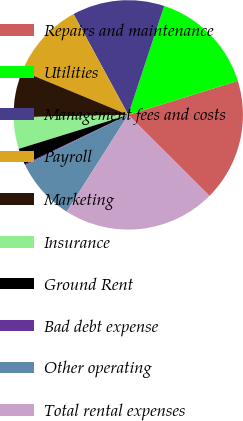Convert chart. <chart><loc_0><loc_0><loc_500><loc_500><pie_chart><fcel>Repairs and maintenance<fcel>Utilities<fcel>Management fees and costs<fcel>Payroll<fcel>Marketing<fcel>Insurance<fcel>Ground Rent<fcel>Bad debt expense<fcel>Other operating<fcel>Total rental expenses<nl><fcel>17.27%<fcel>15.13%<fcel>12.99%<fcel>10.85%<fcel>6.58%<fcel>4.44%<fcel>2.31%<fcel>0.17%<fcel>8.72%<fcel>21.54%<nl></chart> 